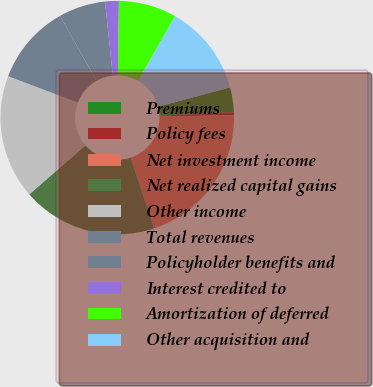<chart> <loc_0><loc_0><loc_500><loc_500><pie_chart><fcel>Premiums<fcel>Policy fees<fcel>Net investment income<fcel>Net realized capital gains<fcel>Other income<fcel>Total revenues<fcel>Policyholder benefits and<fcel>Interest credited to<fcel>Amortization of deferred<fcel>Other acquisition and<nl><fcel>3.43%<fcel>0.38%<fcel>20.23%<fcel>18.71%<fcel>17.18%<fcel>11.07%<fcel>6.49%<fcel>1.9%<fcel>8.01%<fcel>12.6%<nl></chart> 